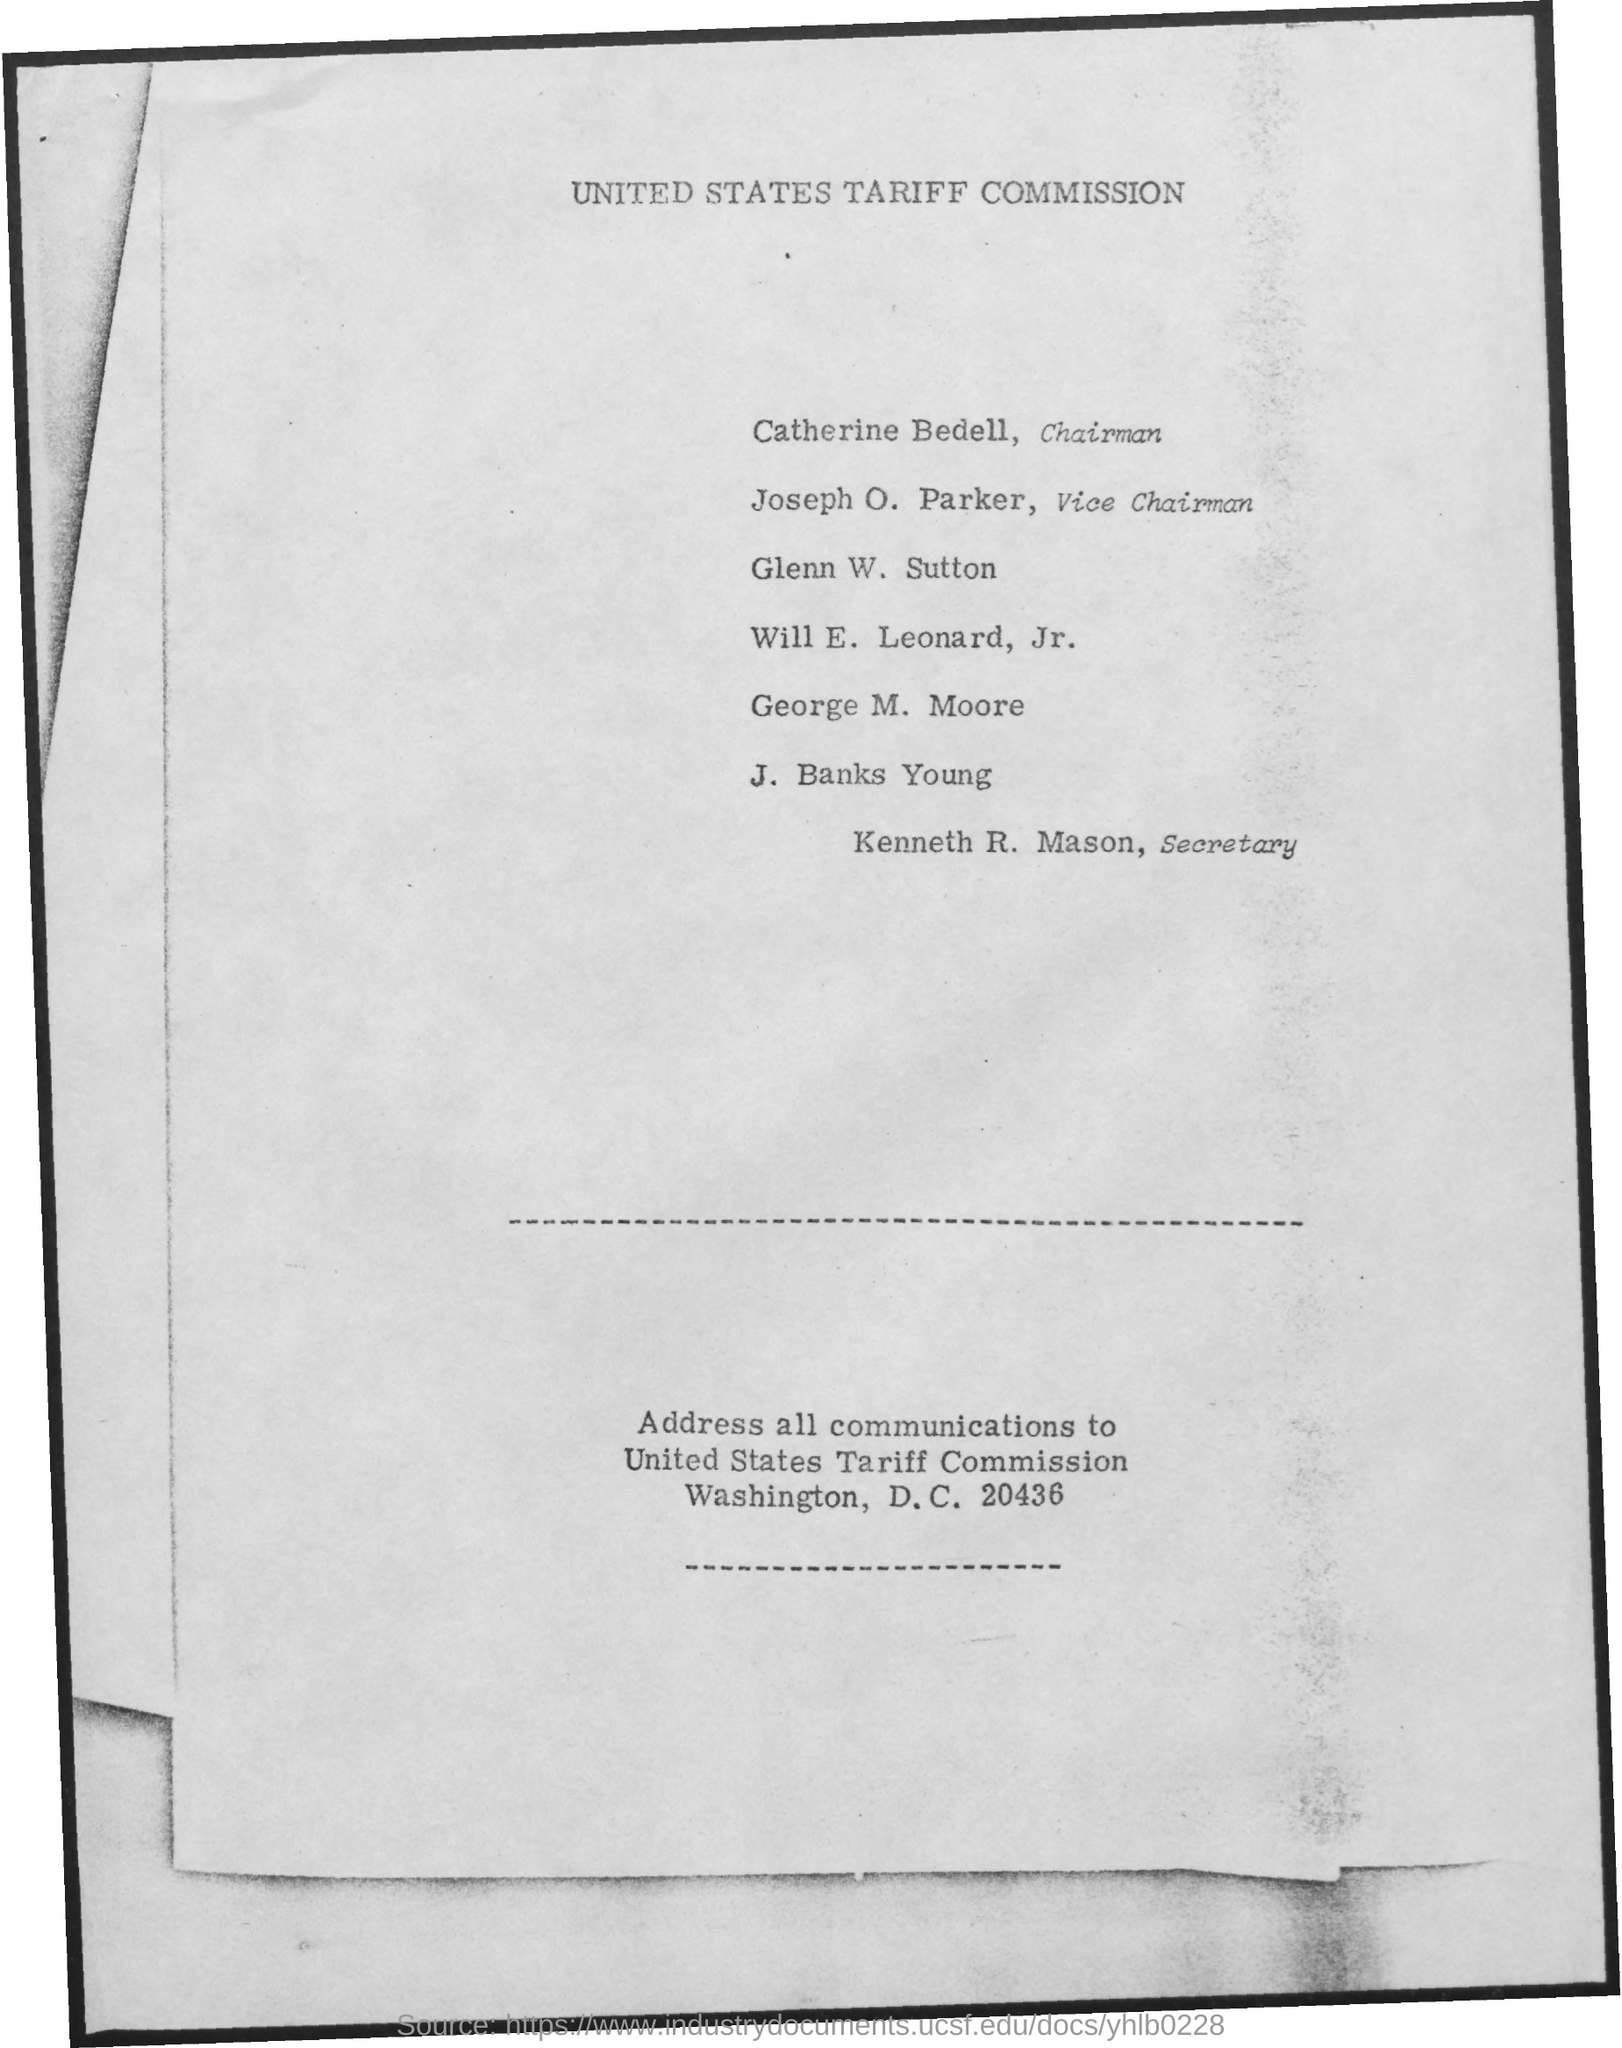What is the name of the commission mentioned ?
Provide a succinct answer. United States Tariff Commission. What is the name of the chairman mentioned ?
Offer a very short reply. Catherine bedell. What is the name of the vice chairman mentioned ?
Offer a terse response. Joseph o. parker. What is the name of the secretary mentioned ?
Give a very brief answer. Kenneth R. Mason. 